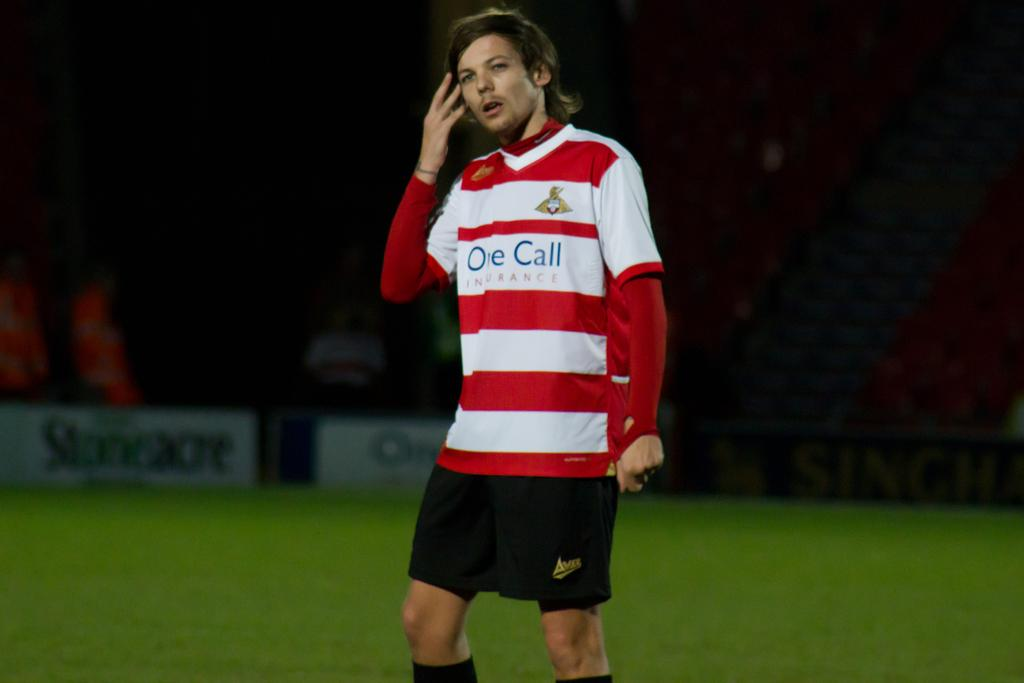<image>
Describe the image concisely. a man with the word call on his soccer jersey 